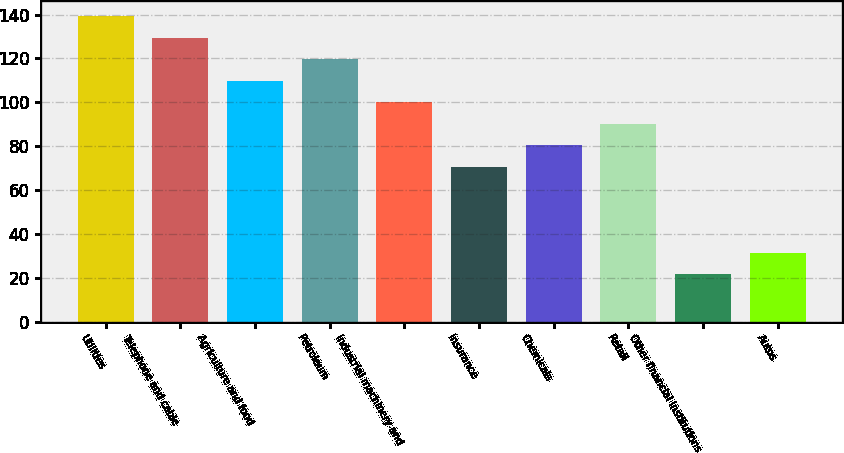Convert chart. <chart><loc_0><loc_0><loc_500><loc_500><bar_chart><fcel>Utilities<fcel>Telephone and cable<fcel>Agriculture and food<fcel>Petroleum<fcel>Industrial machinery and<fcel>Insurance<fcel>Chemicals<fcel>Retail<fcel>Other financial institutions<fcel>Autos<nl><fcel>139.2<fcel>129.4<fcel>109.8<fcel>119.6<fcel>100<fcel>70.6<fcel>80.4<fcel>90.2<fcel>21.6<fcel>31.4<nl></chart> 